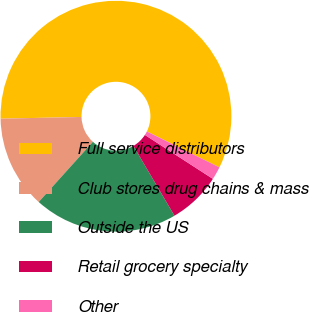Convert chart to OTSL. <chart><loc_0><loc_0><loc_500><loc_500><pie_chart><fcel>Full service distributors<fcel>Club stores drug chains & mass<fcel>Outside the US<fcel>Retail grocery specialty<fcel>Other<nl><fcel>57.64%<fcel>12.99%<fcel>20.13%<fcel>7.41%<fcel>1.83%<nl></chart> 